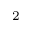<formula> <loc_0><loc_0><loc_500><loc_500>_ { 2 }</formula> 